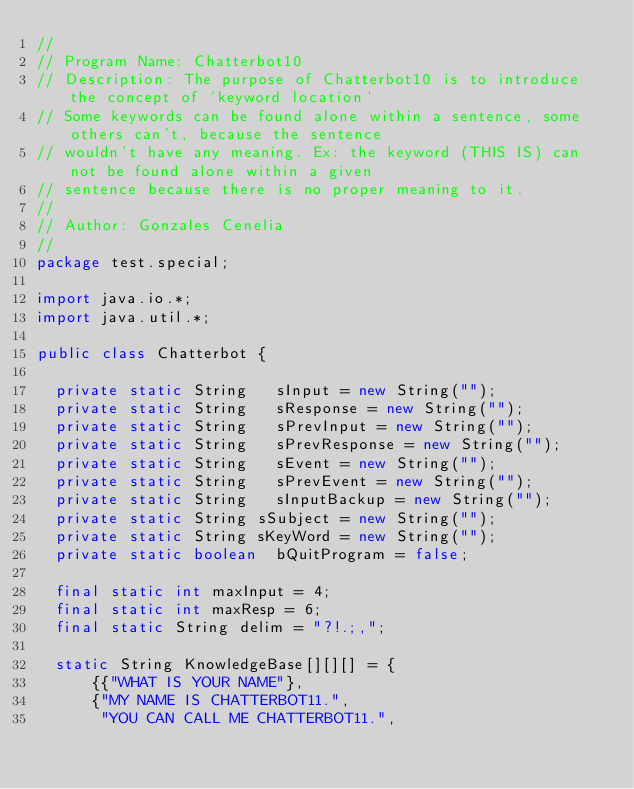<code> <loc_0><loc_0><loc_500><loc_500><_Java_>//
// Program Name: Chatterbot10
// Description: The purpose of Chatterbot10 is to introduce the concept of 'keyword location'
// Some keywords can be found alone within a sentence, some others can't, because the sentence
// wouldn't have any meaning. Ex: the keyword (THIS IS) can not be found alone within a given
// sentence because there is no proper meaning to it.
//
// Author: Gonzales Cenelia
//
package test.special;

import java.io.*;
import java.util.*;

public class Chatterbot {
	
	private static String  	sInput = new String("");
	private static String  	sResponse = new String("");
	private static String  	sPrevInput = new String("");
	private static String  	sPrevResponse = new String("");
	private static String  	sEvent = new String("");
	private static String  	sPrevEvent = new String("");
	private static String  	sInputBackup = new String("");
	private static String	sSubject = new String("");
	private static String	sKeyWord = new String("");
	private static boolean	bQuitProgram = false;
	
	final static int maxInput = 4;
	final static int maxResp = 6;
	final static String delim = "?!.;,";
	
	static String KnowledgeBase[][][] = {
			{{"WHAT IS YOUR NAME"}, 
			{"MY NAME IS CHATTERBOT11.",
			 "YOU CAN CALL ME CHATTERBOT11.",</code> 